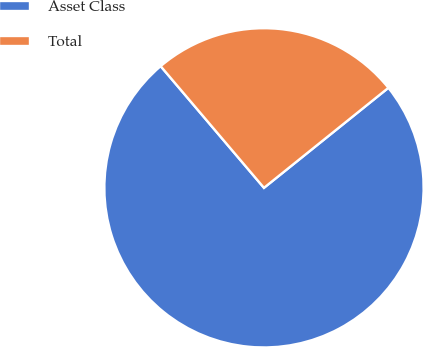Convert chart. <chart><loc_0><loc_0><loc_500><loc_500><pie_chart><fcel>Asset Class<fcel>Total<nl><fcel>74.57%<fcel>25.43%<nl></chart> 